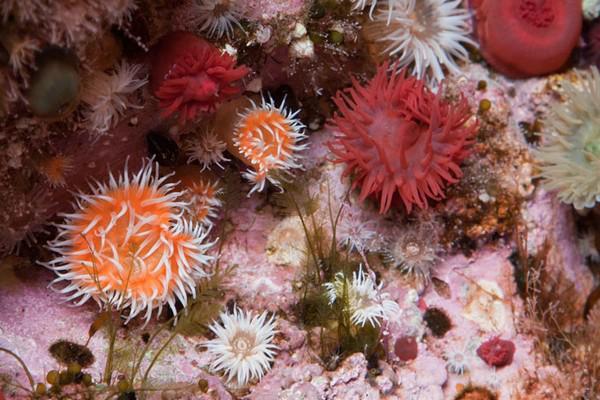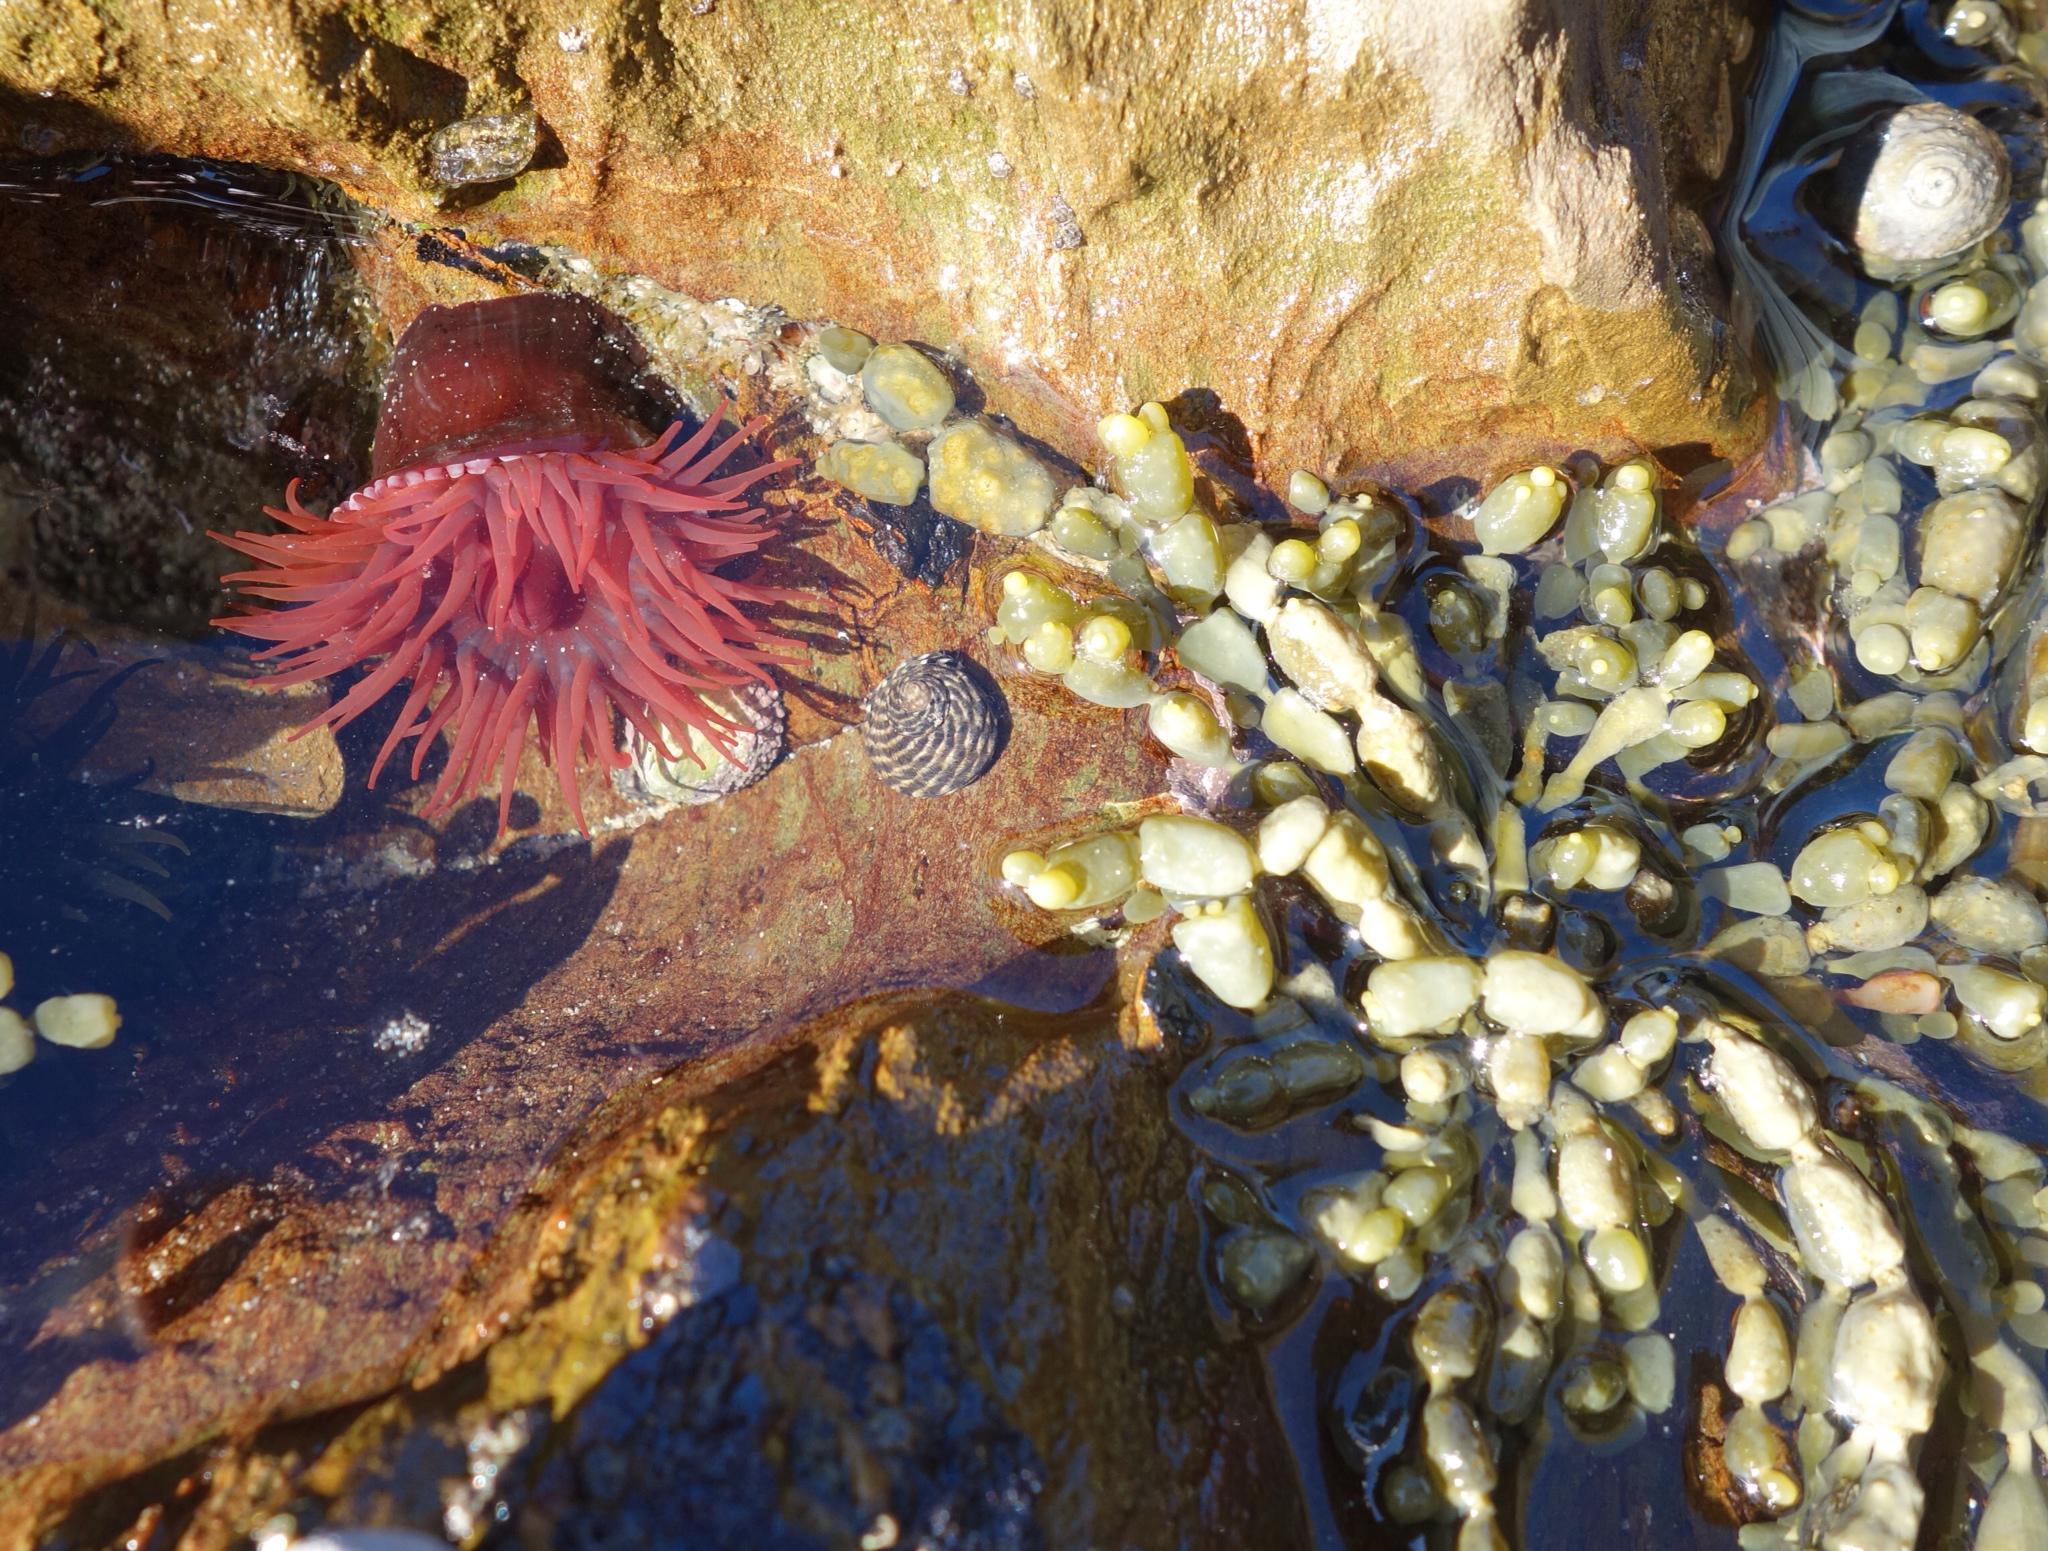The first image is the image on the left, the second image is the image on the right. Examine the images to the left and right. Is the description "Each image contains one prominent roundish marine creature, and the image on the left shows an anemone with tapered orangish tendrils radiating from a center." accurate? Answer yes or no. No. 